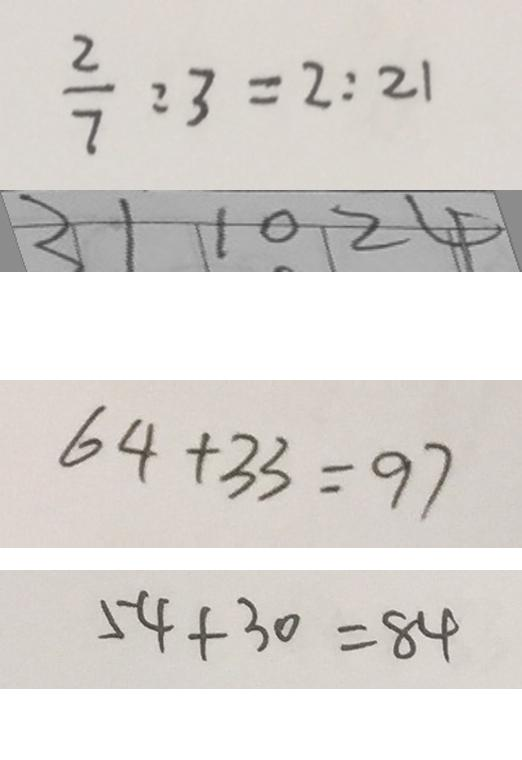<formula> <loc_0><loc_0><loc_500><loc_500>\frac { 2 } { 7 } : 3 = 2 : 2 1 
 3 1 1 0 2 4 
 6 4 + 3 3 = 9 7 
 5 4 + 3 0 = 8 4</formula> 